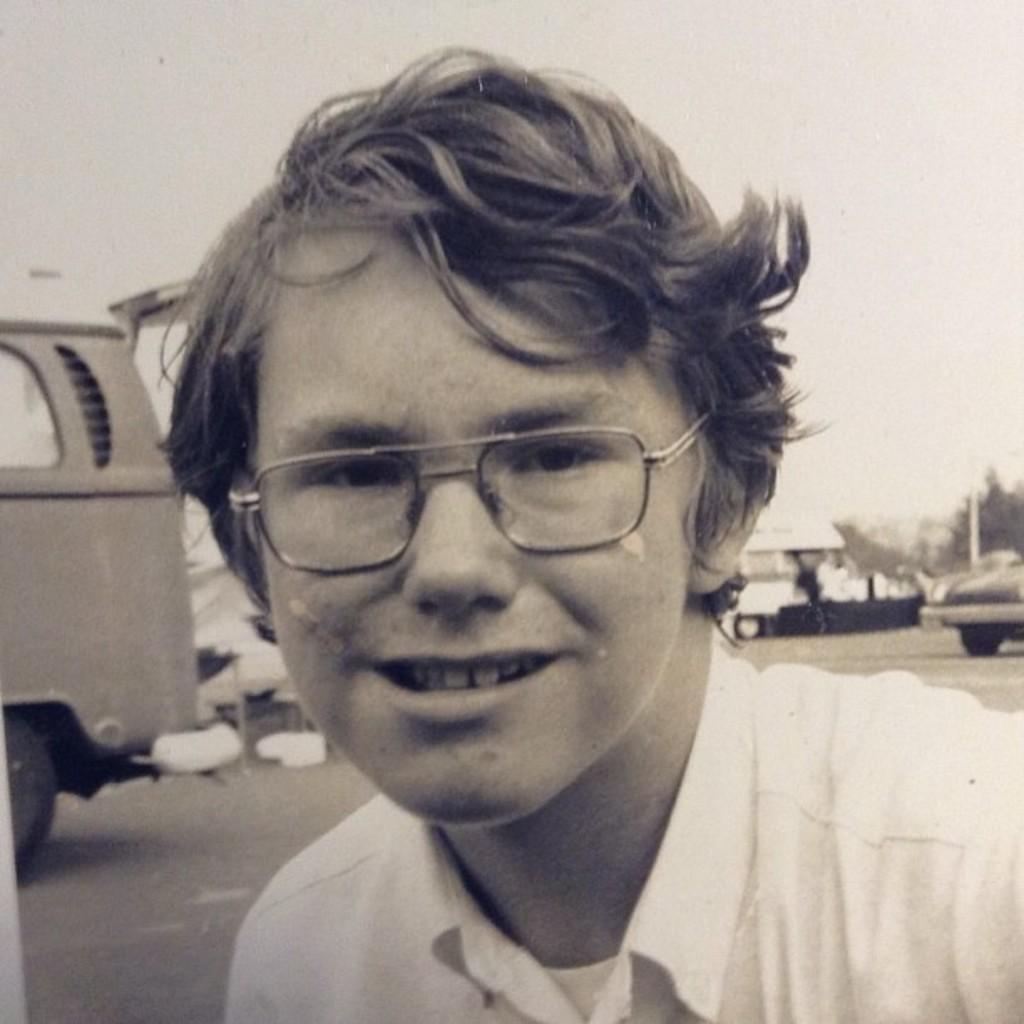How would you summarize this image in a sentence or two? This is a black and white image. There is a person in the middle. He is wearing specs. There are some vehicles behind him. 